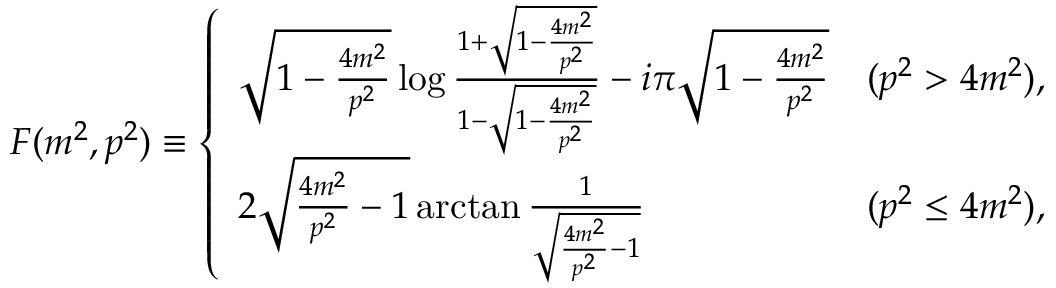Convert formula to latex. <formula><loc_0><loc_0><loc_500><loc_500>F ( m ^ { 2 } , p ^ { 2 } ) \equiv \left \{ \begin{array} { l c } { { \sqrt { 1 - \frac { 4 m ^ { 2 } } { p ^ { 2 } } } \log \frac { 1 + \sqrt { 1 - \frac { 4 m ^ { 2 } } { p ^ { 2 } } } } { 1 - \sqrt { 1 - \frac { 4 m ^ { 2 } } { p ^ { 2 } } } } - i \pi \sqrt { 1 - \frac { 4 m ^ { 2 } } { p ^ { 2 } } } } } & { { ( p ^ { 2 } > 4 m ^ { 2 } ) , } } \\ { { 2 \sqrt { \frac { 4 m ^ { 2 } } { p ^ { 2 } } - 1 } \arctan \frac { 1 } { \sqrt { \frac { 4 m ^ { 2 } } { p ^ { 2 } } - 1 } } } } & { { ( p ^ { 2 } \leq 4 m ^ { 2 } ) , } } \end{array}</formula> 